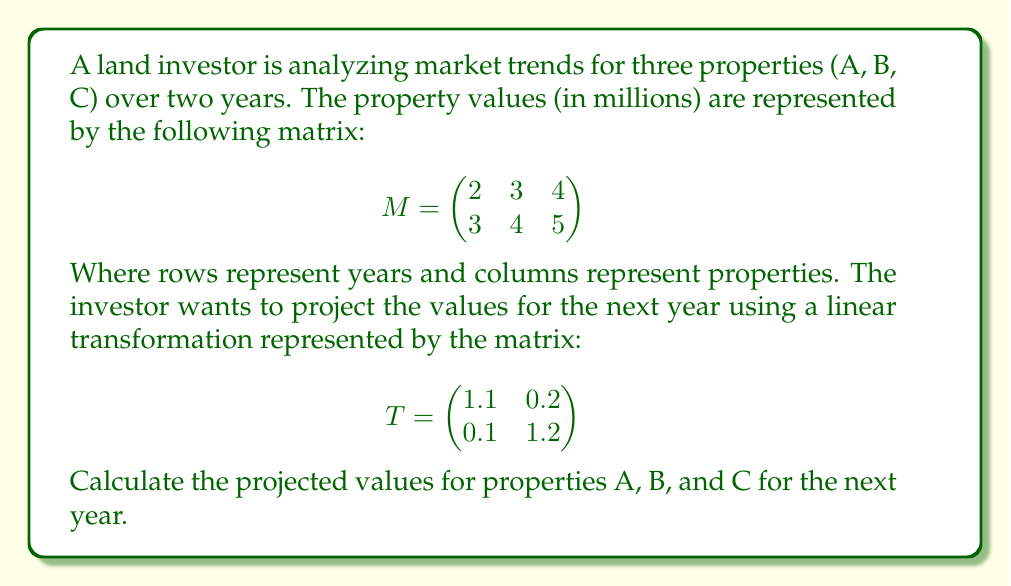Show me your answer to this math problem. To find the projected values for the next year, we need to multiply the transformation matrix T by the property value matrix M. This is done using matrix multiplication:

1) First, let's recall the formula for matrix multiplication:
   $$(TM)_{ij} = \sum_{k=1}^n T_{ik}M_{kj}$$

2) We'll multiply T (2x2) by M (2x3) to get a new 2x3 matrix:

   $$TM = \begin{pmatrix}
   1.1 & 0.2 \\
   0.1 & 1.2
   \end{pmatrix} \begin{pmatrix}
   2 & 3 & 4 \\
   3 & 4 & 5
   \end{pmatrix}$$

3) Let's calculate each element of the resulting matrix:

   For property A:
   $$(TM)_{11} = 1.1(2) + 0.2(3) = 2.2 + 0.6 = 2.8$$
   $$(TM)_{21} = 0.1(2) + 1.2(3) = 0.2 + 3.6 = 3.8$$

   For property B:
   $$(TM)_{12} = 1.1(3) + 0.2(4) = 3.3 + 0.8 = 4.1$$
   $$(TM)_{22} = 0.1(3) + 1.2(4) = 0.3 + 4.8 = 5.1$$

   For property C:
   $$(TM)_{13} = 1.1(4) + 0.2(5) = 4.4 + 1.0 = 5.4$$
   $$(TM)_{23} = 0.1(4) + 1.2(5) = 0.4 + 6.0 = 6.4$$

4) The resulting matrix is:

   $$TM = \begin{pmatrix}
   2.8 & 4.1 & 5.4 \\
   3.8 & 5.1 & 6.4
   \end{pmatrix}$$

5) The second row of this matrix represents the projected values for the next year.

Therefore, the projected values for properties A, B, and C for the next year are 3.8, 5.1, and 6.4 million dollars, respectively.
Answer: (3.8, 5.1, 6.4) 